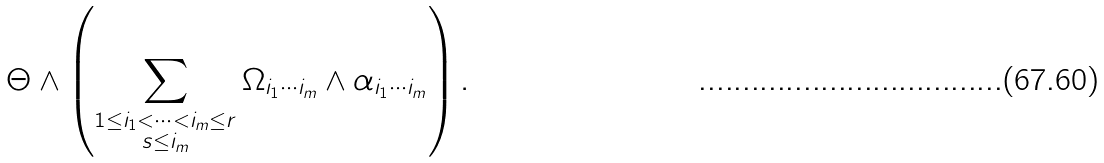Convert formula to latex. <formula><loc_0><loc_0><loc_500><loc_500>\Theta \wedge \left ( \sum _ { \substack { 1 \leq i _ { 1 } < \cdots < i _ { m } \leq r \\ s \leq i _ { m } } } \Omega _ { i _ { 1 } \cdots i _ { m } } \wedge \alpha _ { i _ { 1 } \cdots i _ { m } } \right ) .</formula> 